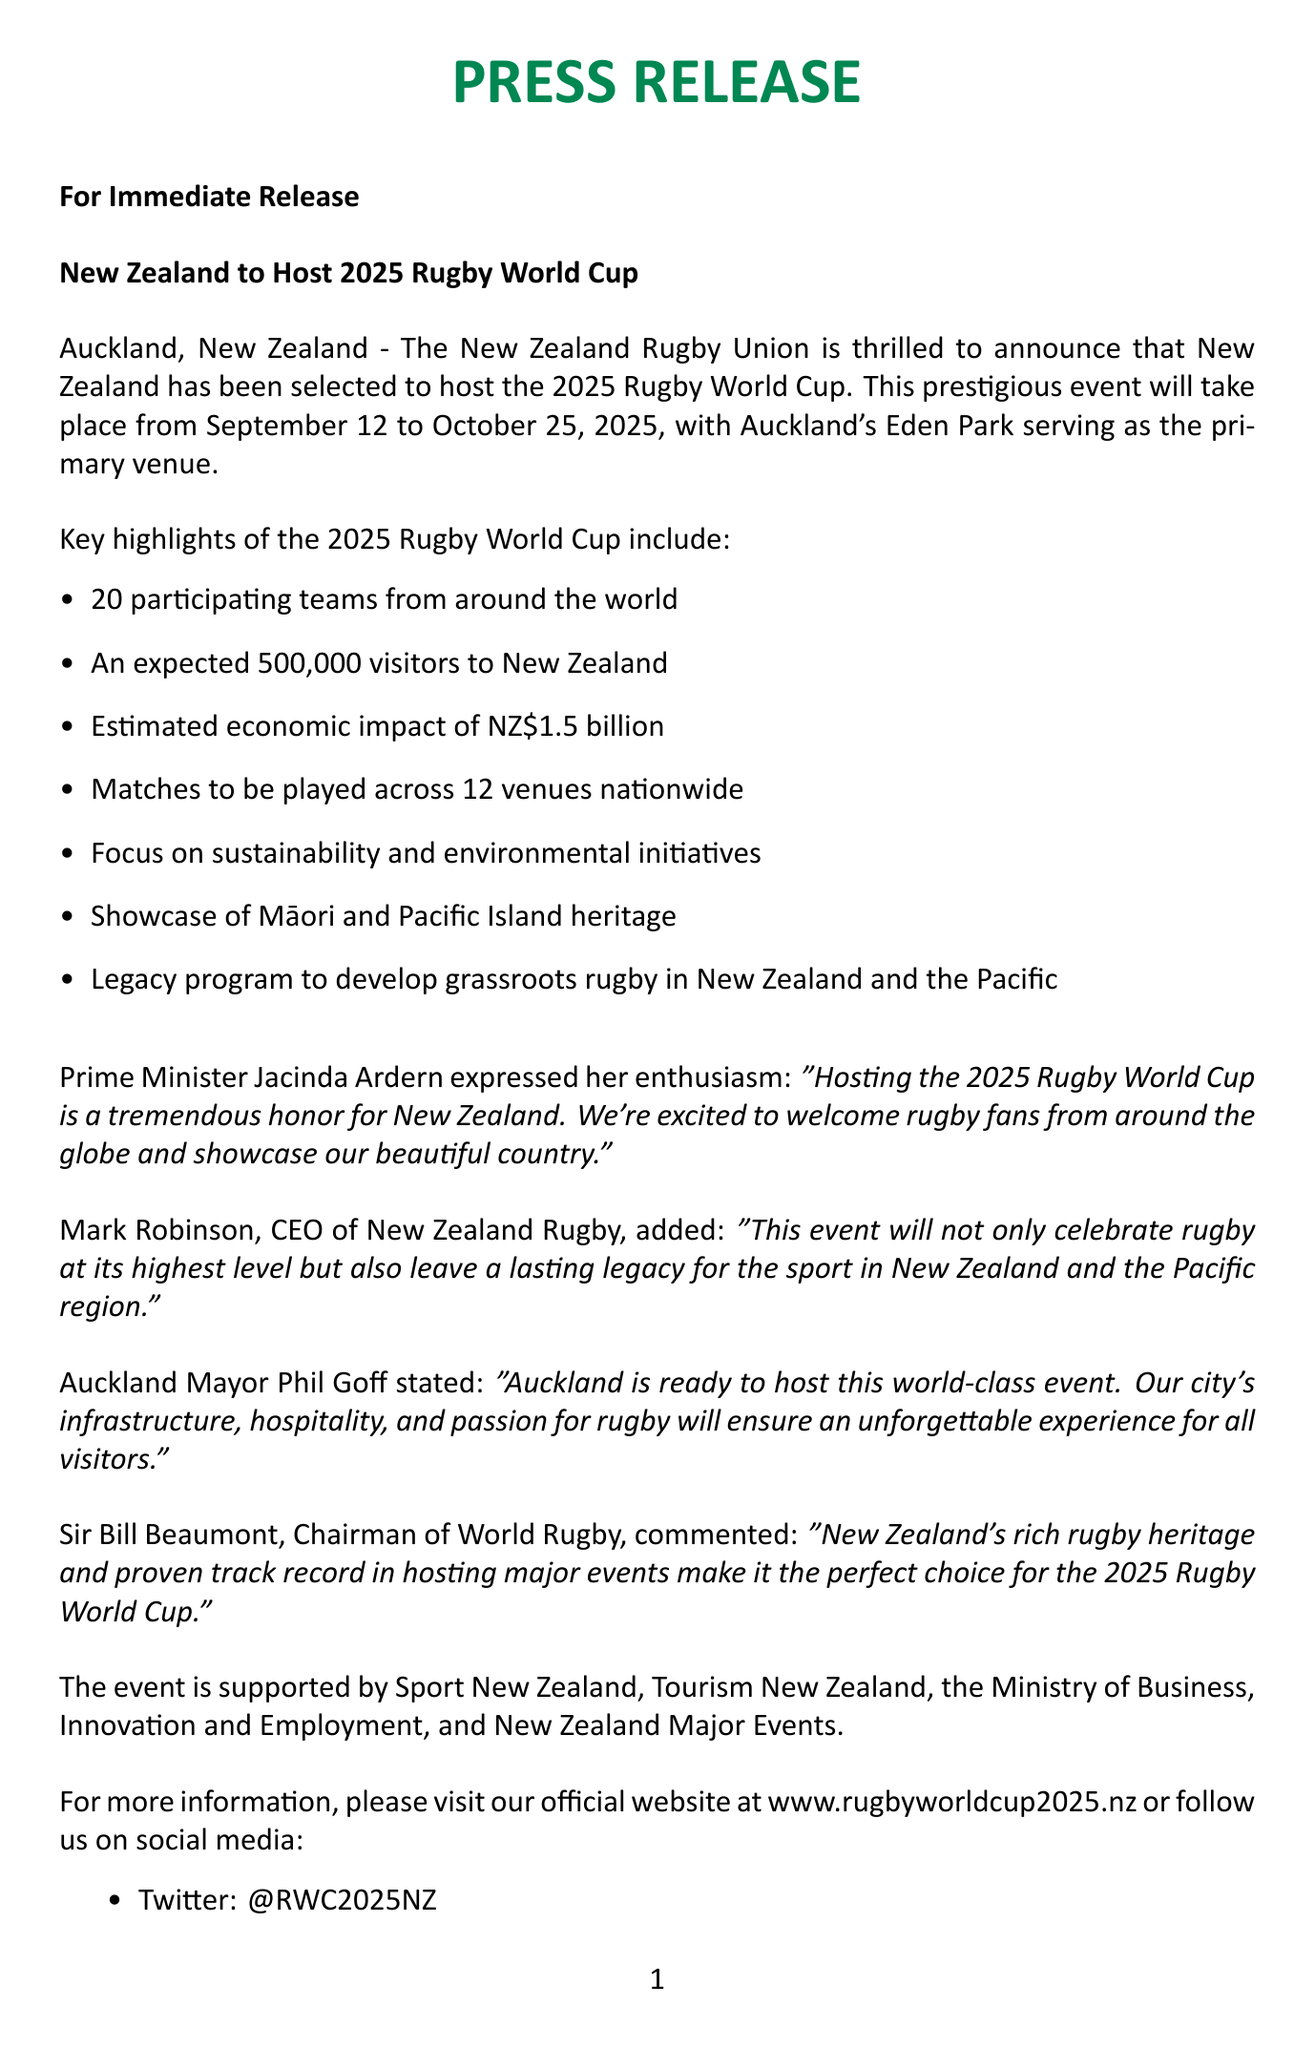What is the event name? The document specifies the name of the event being announced, which is the 2025 Rugby World Cup.
Answer: 2025 Rugby World Cup Where will the event be held? The document identifies the host city for the event, which is Auckland, New Zealand.
Answer: Auckland What are the dates of the event? The press release provides the specific dates during which the sporting event will take place.
Answer: September 12 - October 25, 2025 How many teams will participate? The document states the number of teams that will be part of the event.
Answer: 20 What is the expected economic impact? The document outlines the anticipated financial benefit of the event for the local economy.
Answer: NZ$1.5 billion Who is the CEO of New Zealand Rugby? The press release includes the name of a key stakeholder along with their position.
Answer: Mark Robinson What is the focus of the event regarding the environment? The document mentions a specific theme that the organization aims to emphasize during the event.
Answer: Sustainability and environmental initiatives What is the media contact’s email? The document provides the email contact for media inquiries related to the event.
Answer: sarah.thompson@nzrugby2025.co.nz Which venue will be the primary location for the matches? The press release specifies the main venue where the event will be hosted.
Answer: Eden Park 